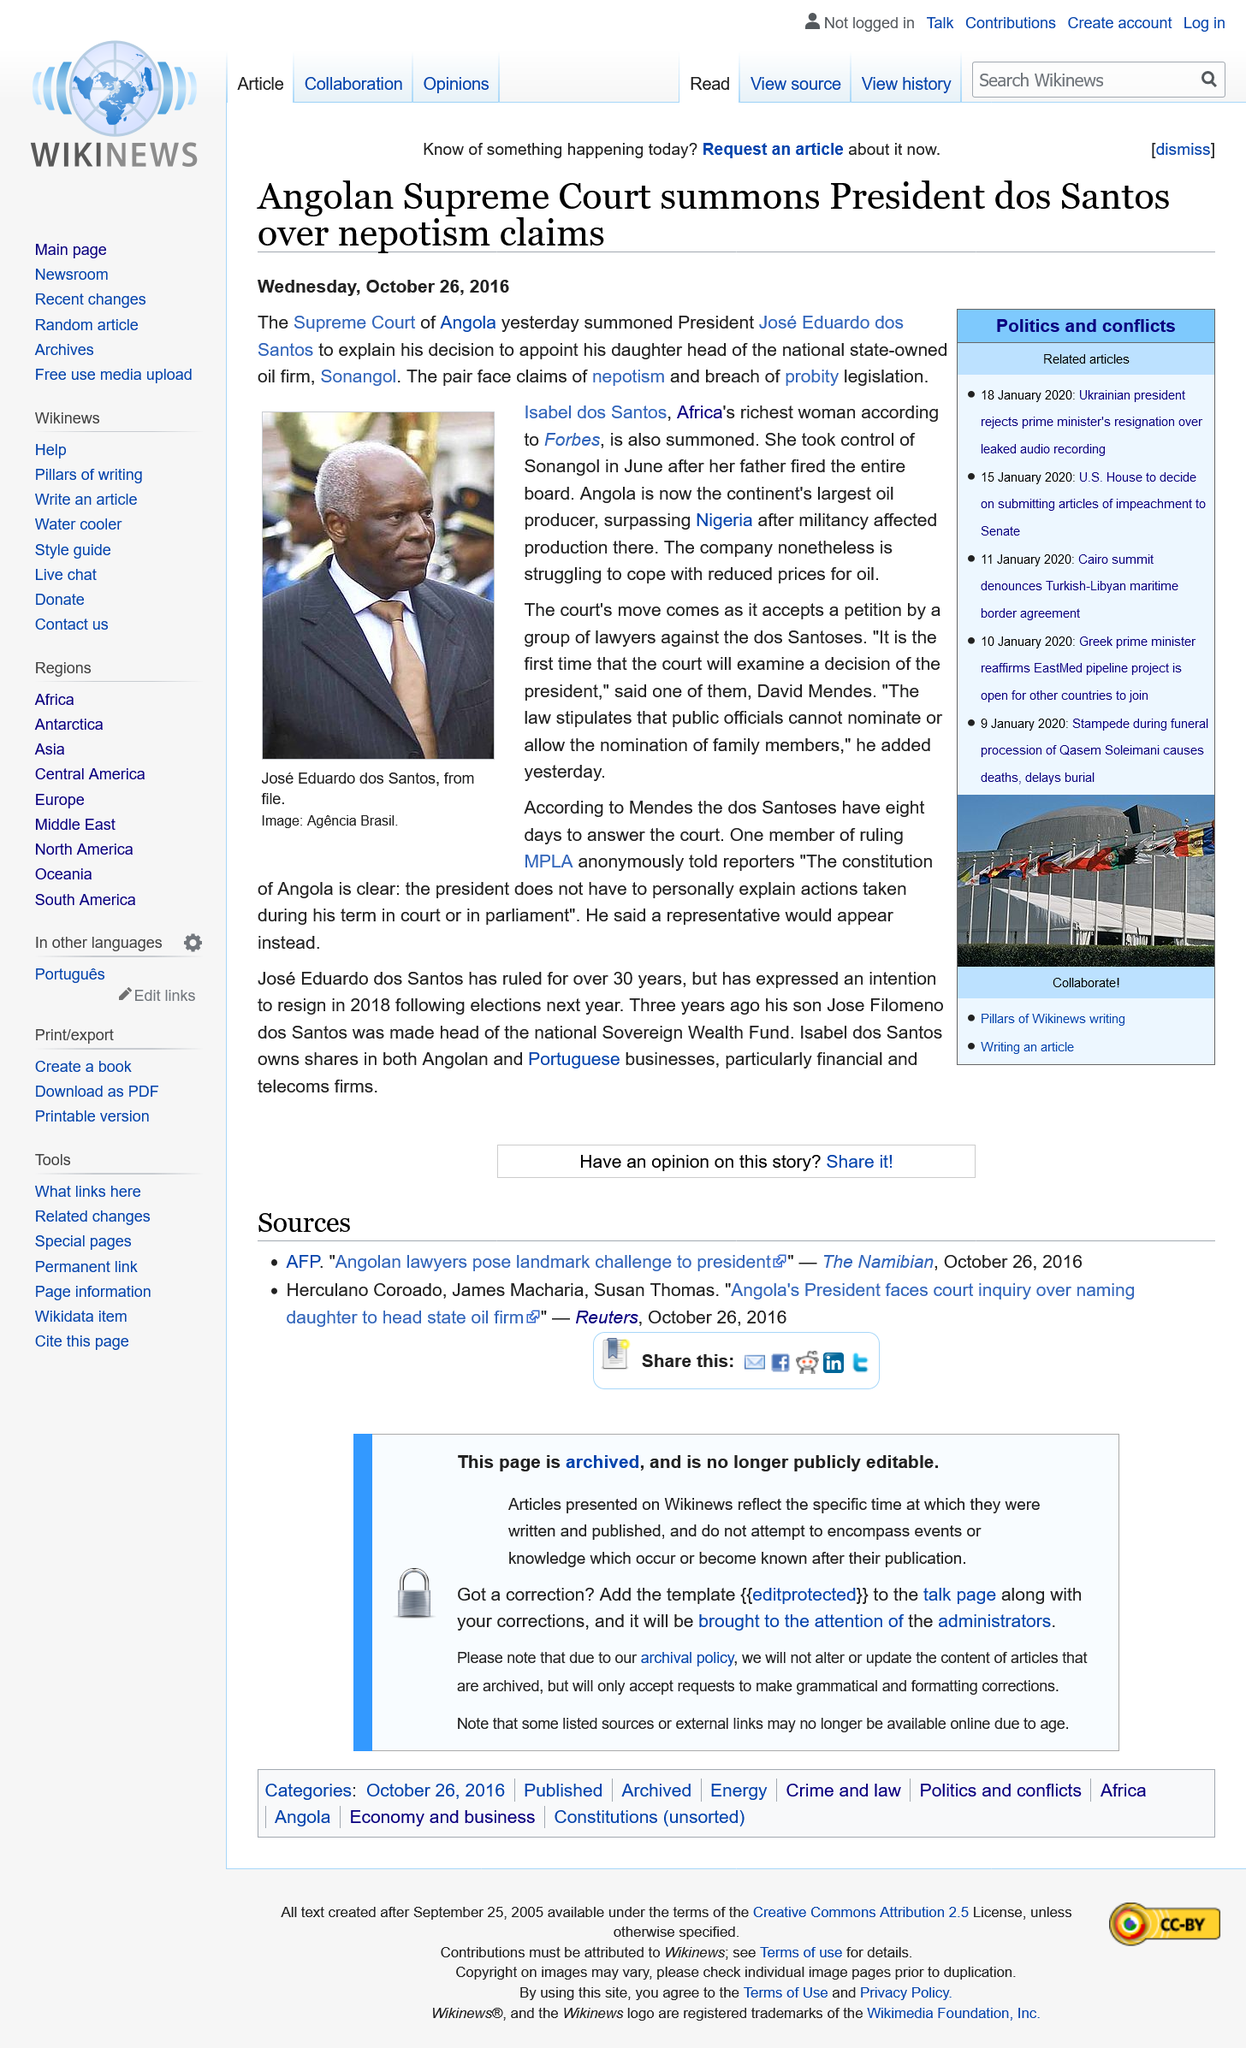Draw attention to some important aspects in this diagram. The person in the photograph is identified as Jose Eduardo dos Santos. Isabel dos Santos is recognized as Africa's richest woman by Forbes. The date on which this text was written is Wednesday, October 26, 2016. 